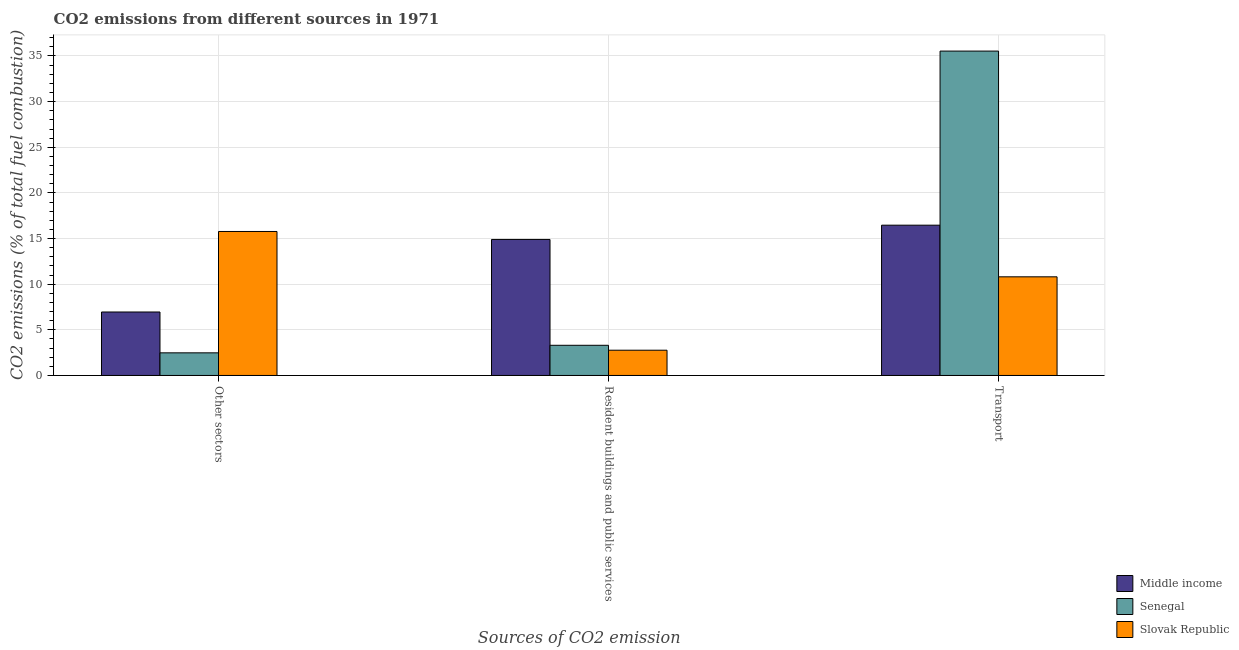How many different coloured bars are there?
Offer a very short reply. 3. How many bars are there on the 1st tick from the left?
Offer a terse response. 3. What is the label of the 1st group of bars from the left?
Provide a short and direct response. Other sectors. What is the percentage of co2 emissions from other sectors in Middle income?
Keep it short and to the point. 6.95. Across all countries, what is the maximum percentage of co2 emissions from resident buildings and public services?
Provide a short and direct response. 14.9. Across all countries, what is the minimum percentage of co2 emissions from other sectors?
Provide a short and direct response. 2.48. In which country was the percentage of co2 emissions from transport maximum?
Make the answer very short. Senegal. In which country was the percentage of co2 emissions from transport minimum?
Your answer should be compact. Slovak Republic. What is the total percentage of co2 emissions from resident buildings and public services in the graph?
Your answer should be very brief. 20.97. What is the difference between the percentage of co2 emissions from other sectors in Senegal and that in Slovak Republic?
Offer a very short reply. -13.3. What is the difference between the percentage of co2 emissions from other sectors in Senegal and the percentage of co2 emissions from transport in Middle income?
Provide a short and direct response. -13.98. What is the average percentage of co2 emissions from other sectors per country?
Provide a succinct answer. 8.4. What is the difference between the percentage of co2 emissions from other sectors and percentage of co2 emissions from resident buildings and public services in Senegal?
Offer a very short reply. -0.83. In how many countries, is the percentage of co2 emissions from other sectors greater than 20 %?
Offer a very short reply. 0. What is the ratio of the percentage of co2 emissions from resident buildings and public services in Slovak Republic to that in Middle income?
Your answer should be very brief. 0.19. Is the percentage of co2 emissions from transport in Middle income less than that in Slovak Republic?
Ensure brevity in your answer.  No. What is the difference between the highest and the second highest percentage of co2 emissions from resident buildings and public services?
Provide a succinct answer. 11.6. What is the difference between the highest and the lowest percentage of co2 emissions from other sectors?
Offer a very short reply. 13.3. In how many countries, is the percentage of co2 emissions from resident buildings and public services greater than the average percentage of co2 emissions from resident buildings and public services taken over all countries?
Provide a succinct answer. 1. What does the 1st bar from the right in Other sectors represents?
Your answer should be compact. Slovak Republic. How many countries are there in the graph?
Your answer should be very brief. 3. What is the difference between two consecutive major ticks on the Y-axis?
Your answer should be very brief. 5. Are the values on the major ticks of Y-axis written in scientific E-notation?
Keep it short and to the point. No. Does the graph contain grids?
Your answer should be very brief. Yes. Where does the legend appear in the graph?
Keep it short and to the point. Bottom right. How many legend labels are there?
Offer a terse response. 3. How are the legend labels stacked?
Make the answer very short. Vertical. What is the title of the graph?
Provide a short and direct response. CO2 emissions from different sources in 1971. What is the label or title of the X-axis?
Your answer should be very brief. Sources of CO2 emission. What is the label or title of the Y-axis?
Your answer should be compact. CO2 emissions (% of total fuel combustion). What is the CO2 emissions (% of total fuel combustion) of Middle income in Other sectors?
Provide a succinct answer. 6.95. What is the CO2 emissions (% of total fuel combustion) of Senegal in Other sectors?
Ensure brevity in your answer.  2.48. What is the CO2 emissions (% of total fuel combustion) of Slovak Republic in Other sectors?
Offer a very short reply. 15.77. What is the CO2 emissions (% of total fuel combustion) in Middle income in Resident buildings and public services?
Your answer should be very brief. 14.9. What is the CO2 emissions (% of total fuel combustion) in Senegal in Resident buildings and public services?
Provide a short and direct response. 3.31. What is the CO2 emissions (% of total fuel combustion) of Slovak Republic in Resident buildings and public services?
Your answer should be very brief. 2.77. What is the CO2 emissions (% of total fuel combustion) of Middle income in Transport?
Offer a terse response. 16.46. What is the CO2 emissions (% of total fuel combustion) of Senegal in Transport?
Your answer should be very brief. 35.54. What is the CO2 emissions (% of total fuel combustion) of Slovak Republic in Transport?
Ensure brevity in your answer.  10.81. Across all Sources of CO2 emission, what is the maximum CO2 emissions (% of total fuel combustion) of Middle income?
Make the answer very short. 16.46. Across all Sources of CO2 emission, what is the maximum CO2 emissions (% of total fuel combustion) in Senegal?
Offer a terse response. 35.54. Across all Sources of CO2 emission, what is the maximum CO2 emissions (% of total fuel combustion) of Slovak Republic?
Your answer should be compact. 15.77. Across all Sources of CO2 emission, what is the minimum CO2 emissions (% of total fuel combustion) in Middle income?
Offer a very short reply. 6.95. Across all Sources of CO2 emission, what is the minimum CO2 emissions (% of total fuel combustion) of Senegal?
Ensure brevity in your answer.  2.48. Across all Sources of CO2 emission, what is the minimum CO2 emissions (% of total fuel combustion) in Slovak Republic?
Offer a very short reply. 2.77. What is the total CO2 emissions (% of total fuel combustion) in Middle income in the graph?
Your response must be concise. 38.32. What is the total CO2 emissions (% of total fuel combustion) in Senegal in the graph?
Ensure brevity in your answer.  41.32. What is the total CO2 emissions (% of total fuel combustion) in Slovak Republic in the graph?
Offer a terse response. 29.35. What is the difference between the CO2 emissions (% of total fuel combustion) in Middle income in Other sectors and that in Resident buildings and public services?
Offer a terse response. -7.95. What is the difference between the CO2 emissions (% of total fuel combustion) of Senegal in Other sectors and that in Resident buildings and public services?
Ensure brevity in your answer.  -0.83. What is the difference between the CO2 emissions (% of total fuel combustion) of Slovak Republic in Other sectors and that in Resident buildings and public services?
Provide a succinct answer. 13.01. What is the difference between the CO2 emissions (% of total fuel combustion) in Middle income in Other sectors and that in Transport?
Your response must be concise. -9.51. What is the difference between the CO2 emissions (% of total fuel combustion) in Senegal in Other sectors and that in Transport?
Offer a very short reply. -33.06. What is the difference between the CO2 emissions (% of total fuel combustion) of Slovak Republic in Other sectors and that in Transport?
Ensure brevity in your answer.  4.97. What is the difference between the CO2 emissions (% of total fuel combustion) of Middle income in Resident buildings and public services and that in Transport?
Provide a succinct answer. -1.56. What is the difference between the CO2 emissions (% of total fuel combustion) of Senegal in Resident buildings and public services and that in Transport?
Your answer should be very brief. -32.23. What is the difference between the CO2 emissions (% of total fuel combustion) of Slovak Republic in Resident buildings and public services and that in Transport?
Ensure brevity in your answer.  -8.04. What is the difference between the CO2 emissions (% of total fuel combustion) in Middle income in Other sectors and the CO2 emissions (% of total fuel combustion) in Senegal in Resident buildings and public services?
Make the answer very short. 3.65. What is the difference between the CO2 emissions (% of total fuel combustion) of Middle income in Other sectors and the CO2 emissions (% of total fuel combustion) of Slovak Republic in Resident buildings and public services?
Offer a very short reply. 4.19. What is the difference between the CO2 emissions (% of total fuel combustion) of Senegal in Other sectors and the CO2 emissions (% of total fuel combustion) of Slovak Republic in Resident buildings and public services?
Give a very brief answer. -0.29. What is the difference between the CO2 emissions (% of total fuel combustion) in Middle income in Other sectors and the CO2 emissions (% of total fuel combustion) in Senegal in Transport?
Your answer should be compact. -28.58. What is the difference between the CO2 emissions (% of total fuel combustion) of Middle income in Other sectors and the CO2 emissions (% of total fuel combustion) of Slovak Republic in Transport?
Keep it short and to the point. -3.85. What is the difference between the CO2 emissions (% of total fuel combustion) in Senegal in Other sectors and the CO2 emissions (% of total fuel combustion) in Slovak Republic in Transport?
Give a very brief answer. -8.33. What is the difference between the CO2 emissions (% of total fuel combustion) of Middle income in Resident buildings and public services and the CO2 emissions (% of total fuel combustion) of Senegal in Transport?
Your answer should be very brief. -20.63. What is the difference between the CO2 emissions (% of total fuel combustion) in Middle income in Resident buildings and public services and the CO2 emissions (% of total fuel combustion) in Slovak Republic in Transport?
Your answer should be very brief. 4.1. What is the difference between the CO2 emissions (% of total fuel combustion) in Senegal in Resident buildings and public services and the CO2 emissions (% of total fuel combustion) in Slovak Republic in Transport?
Give a very brief answer. -7.5. What is the average CO2 emissions (% of total fuel combustion) of Middle income per Sources of CO2 emission?
Offer a terse response. 12.77. What is the average CO2 emissions (% of total fuel combustion) in Senegal per Sources of CO2 emission?
Offer a terse response. 13.77. What is the average CO2 emissions (% of total fuel combustion) of Slovak Republic per Sources of CO2 emission?
Provide a short and direct response. 9.78. What is the difference between the CO2 emissions (% of total fuel combustion) of Middle income and CO2 emissions (% of total fuel combustion) of Senegal in Other sectors?
Provide a succinct answer. 4.47. What is the difference between the CO2 emissions (% of total fuel combustion) of Middle income and CO2 emissions (% of total fuel combustion) of Slovak Republic in Other sectors?
Offer a terse response. -8.82. What is the difference between the CO2 emissions (% of total fuel combustion) of Senegal and CO2 emissions (% of total fuel combustion) of Slovak Republic in Other sectors?
Your answer should be very brief. -13.3. What is the difference between the CO2 emissions (% of total fuel combustion) in Middle income and CO2 emissions (% of total fuel combustion) in Senegal in Resident buildings and public services?
Keep it short and to the point. 11.6. What is the difference between the CO2 emissions (% of total fuel combustion) of Middle income and CO2 emissions (% of total fuel combustion) of Slovak Republic in Resident buildings and public services?
Your answer should be very brief. 12.14. What is the difference between the CO2 emissions (% of total fuel combustion) in Senegal and CO2 emissions (% of total fuel combustion) in Slovak Republic in Resident buildings and public services?
Ensure brevity in your answer.  0.54. What is the difference between the CO2 emissions (% of total fuel combustion) in Middle income and CO2 emissions (% of total fuel combustion) in Senegal in Transport?
Ensure brevity in your answer.  -19.07. What is the difference between the CO2 emissions (% of total fuel combustion) of Middle income and CO2 emissions (% of total fuel combustion) of Slovak Republic in Transport?
Offer a terse response. 5.66. What is the difference between the CO2 emissions (% of total fuel combustion) of Senegal and CO2 emissions (% of total fuel combustion) of Slovak Republic in Transport?
Your answer should be compact. 24.73. What is the ratio of the CO2 emissions (% of total fuel combustion) of Middle income in Other sectors to that in Resident buildings and public services?
Your answer should be very brief. 0.47. What is the ratio of the CO2 emissions (% of total fuel combustion) of Senegal in Other sectors to that in Resident buildings and public services?
Provide a succinct answer. 0.75. What is the ratio of the CO2 emissions (% of total fuel combustion) in Slovak Republic in Other sectors to that in Resident buildings and public services?
Your answer should be very brief. 5.7. What is the ratio of the CO2 emissions (% of total fuel combustion) of Middle income in Other sectors to that in Transport?
Ensure brevity in your answer.  0.42. What is the ratio of the CO2 emissions (% of total fuel combustion) in Senegal in Other sectors to that in Transport?
Your answer should be compact. 0.07. What is the ratio of the CO2 emissions (% of total fuel combustion) of Slovak Republic in Other sectors to that in Transport?
Make the answer very short. 1.46. What is the ratio of the CO2 emissions (% of total fuel combustion) of Middle income in Resident buildings and public services to that in Transport?
Your answer should be very brief. 0.91. What is the ratio of the CO2 emissions (% of total fuel combustion) of Senegal in Resident buildings and public services to that in Transport?
Ensure brevity in your answer.  0.09. What is the ratio of the CO2 emissions (% of total fuel combustion) in Slovak Republic in Resident buildings and public services to that in Transport?
Your answer should be compact. 0.26. What is the difference between the highest and the second highest CO2 emissions (% of total fuel combustion) of Middle income?
Your answer should be very brief. 1.56. What is the difference between the highest and the second highest CO2 emissions (% of total fuel combustion) of Senegal?
Provide a succinct answer. 32.23. What is the difference between the highest and the second highest CO2 emissions (% of total fuel combustion) of Slovak Republic?
Your answer should be compact. 4.97. What is the difference between the highest and the lowest CO2 emissions (% of total fuel combustion) in Middle income?
Keep it short and to the point. 9.51. What is the difference between the highest and the lowest CO2 emissions (% of total fuel combustion) of Senegal?
Make the answer very short. 33.06. What is the difference between the highest and the lowest CO2 emissions (% of total fuel combustion) of Slovak Republic?
Keep it short and to the point. 13.01. 